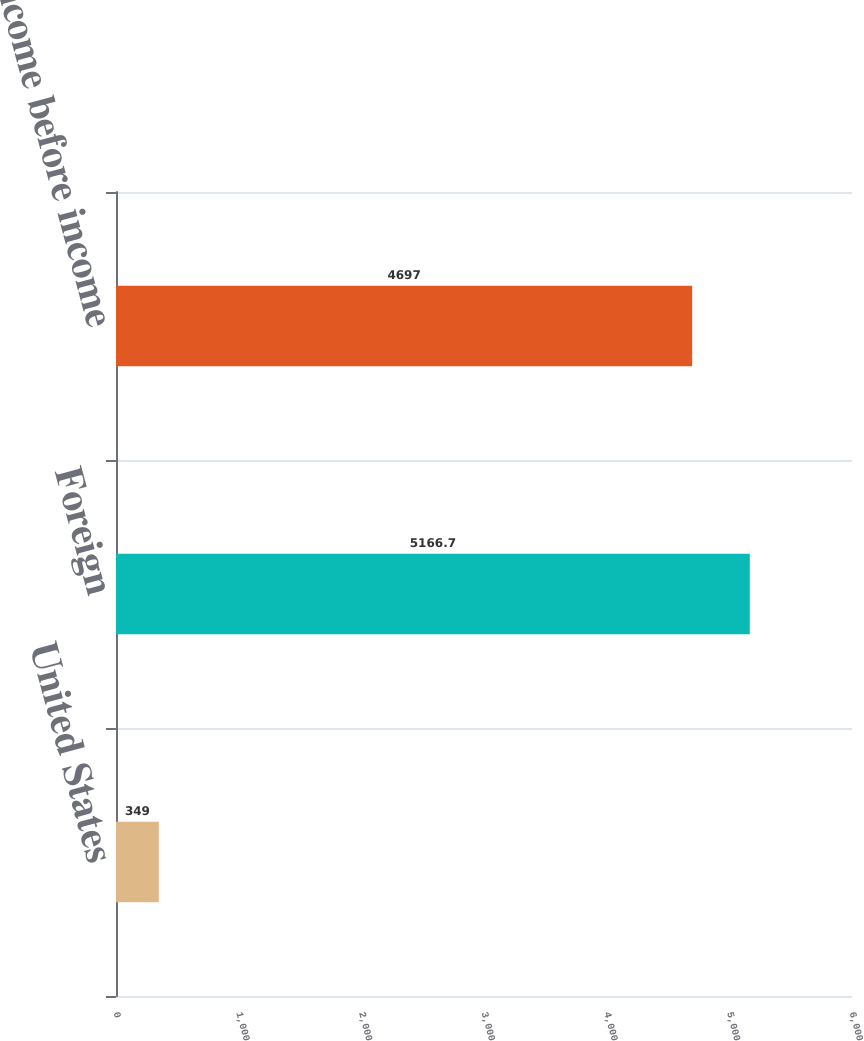Convert chart. <chart><loc_0><loc_0><loc_500><loc_500><bar_chart><fcel>United States<fcel>Foreign<fcel>Total income before income<nl><fcel>349<fcel>5166.7<fcel>4697<nl></chart> 